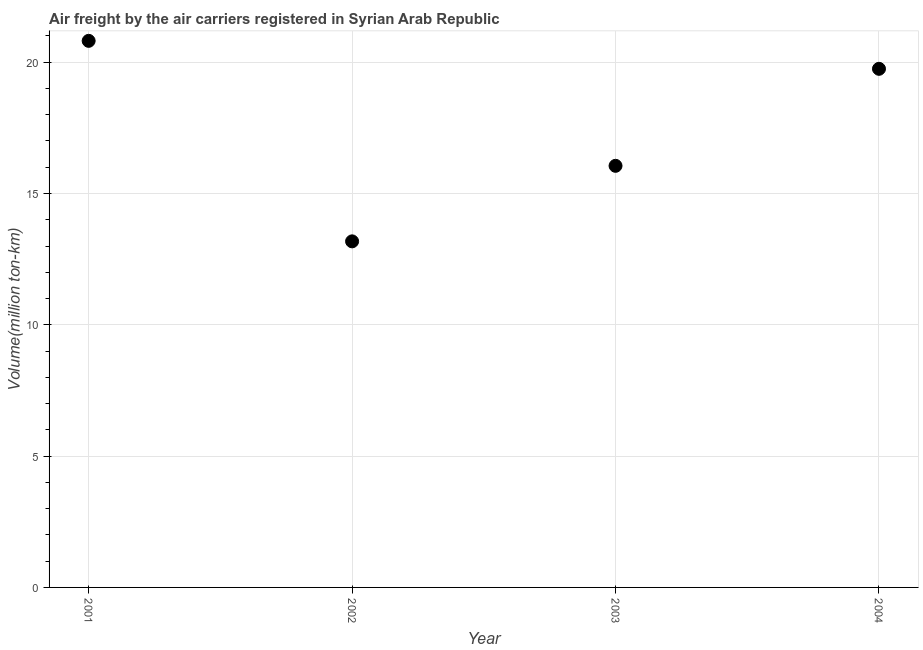What is the air freight in 2001?
Provide a succinct answer. 20.81. Across all years, what is the maximum air freight?
Keep it short and to the point. 20.81. Across all years, what is the minimum air freight?
Provide a short and direct response. 13.18. In which year was the air freight maximum?
Keep it short and to the point. 2001. What is the sum of the air freight?
Keep it short and to the point. 69.79. What is the difference between the air freight in 2001 and 2002?
Offer a very short reply. 7.63. What is the average air freight per year?
Your response must be concise. 17.45. What is the median air freight?
Provide a succinct answer. 17.9. Do a majority of the years between 2004 and 2002 (inclusive) have air freight greater than 1 million ton-km?
Your response must be concise. No. What is the ratio of the air freight in 2002 to that in 2004?
Your answer should be compact. 0.67. What is the difference between the highest and the second highest air freight?
Offer a terse response. 1.06. Is the sum of the air freight in 2002 and 2004 greater than the maximum air freight across all years?
Provide a short and direct response. Yes. What is the difference between the highest and the lowest air freight?
Give a very brief answer. 7.63. Does the air freight monotonically increase over the years?
Offer a very short reply. No. How many dotlines are there?
Offer a terse response. 1. How many years are there in the graph?
Your answer should be compact. 4. Are the values on the major ticks of Y-axis written in scientific E-notation?
Make the answer very short. No. Does the graph contain grids?
Provide a short and direct response. Yes. What is the title of the graph?
Your answer should be very brief. Air freight by the air carriers registered in Syrian Arab Republic. What is the label or title of the X-axis?
Your response must be concise. Year. What is the label or title of the Y-axis?
Keep it short and to the point. Volume(million ton-km). What is the Volume(million ton-km) in 2001?
Keep it short and to the point. 20.81. What is the Volume(million ton-km) in 2002?
Your response must be concise. 13.18. What is the Volume(million ton-km) in 2003?
Provide a short and direct response. 16.05. What is the Volume(million ton-km) in 2004?
Give a very brief answer. 19.75. What is the difference between the Volume(million ton-km) in 2001 and 2002?
Offer a very short reply. 7.63. What is the difference between the Volume(million ton-km) in 2001 and 2003?
Provide a succinct answer. 4.76. What is the difference between the Volume(million ton-km) in 2001 and 2004?
Your response must be concise. 1.06. What is the difference between the Volume(million ton-km) in 2002 and 2003?
Offer a very short reply. -2.88. What is the difference between the Volume(million ton-km) in 2002 and 2004?
Your response must be concise. -6.57. What is the difference between the Volume(million ton-km) in 2003 and 2004?
Your response must be concise. -3.69. What is the ratio of the Volume(million ton-km) in 2001 to that in 2002?
Provide a succinct answer. 1.58. What is the ratio of the Volume(million ton-km) in 2001 to that in 2003?
Keep it short and to the point. 1.3. What is the ratio of the Volume(million ton-km) in 2001 to that in 2004?
Give a very brief answer. 1.05. What is the ratio of the Volume(million ton-km) in 2002 to that in 2003?
Offer a very short reply. 0.82. What is the ratio of the Volume(million ton-km) in 2002 to that in 2004?
Your response must be concise. 0.67. What is the ratio of the Volume(million ton-km) in 2003 to that in 2004?
Your answer should be compact. 0.81. 